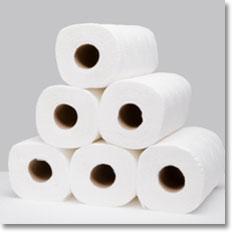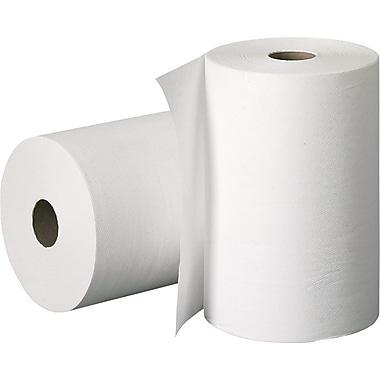The first image is the image on the left, the second image is the image on the right. Evaluate the accuracy of this statement regarding the images: "The left image contains a paper towel stand.". Is it true? Answer yes or no. No. 